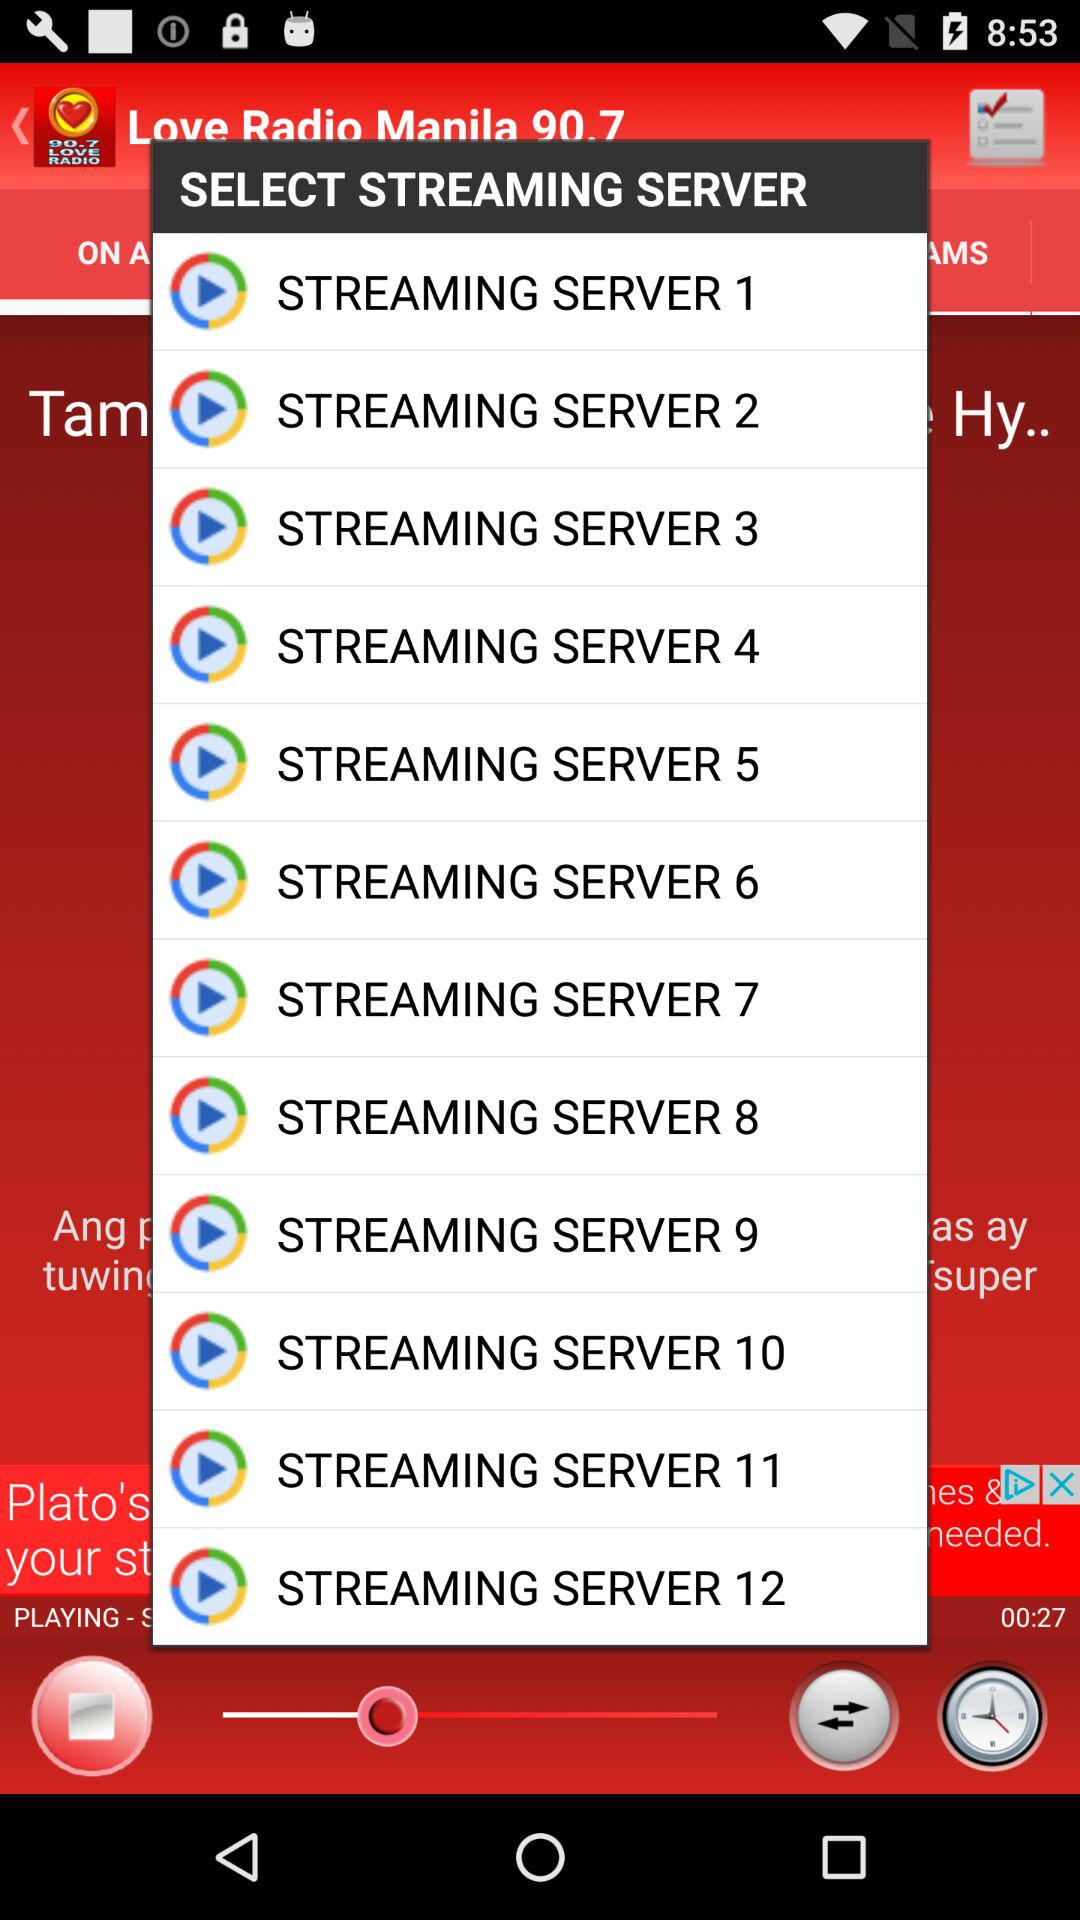What is the duration of the song that is playing now? The duration of the song is 00:27. 